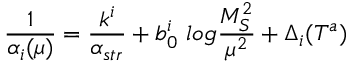<formula> <loc_0><loc_0><loc_500><loc_500>\frac { 1 } { \alpha _ { i } ( \mu ) } = \frac { k ^ { i } } { \alpha _ { s t r } } + b _ { 0 } ^ { i } \log \frac { M _ { S } ^ { 2 } } { \mu ^ { 2 } } + \Delta _ { i } ( T ^ { a } )</formula> 